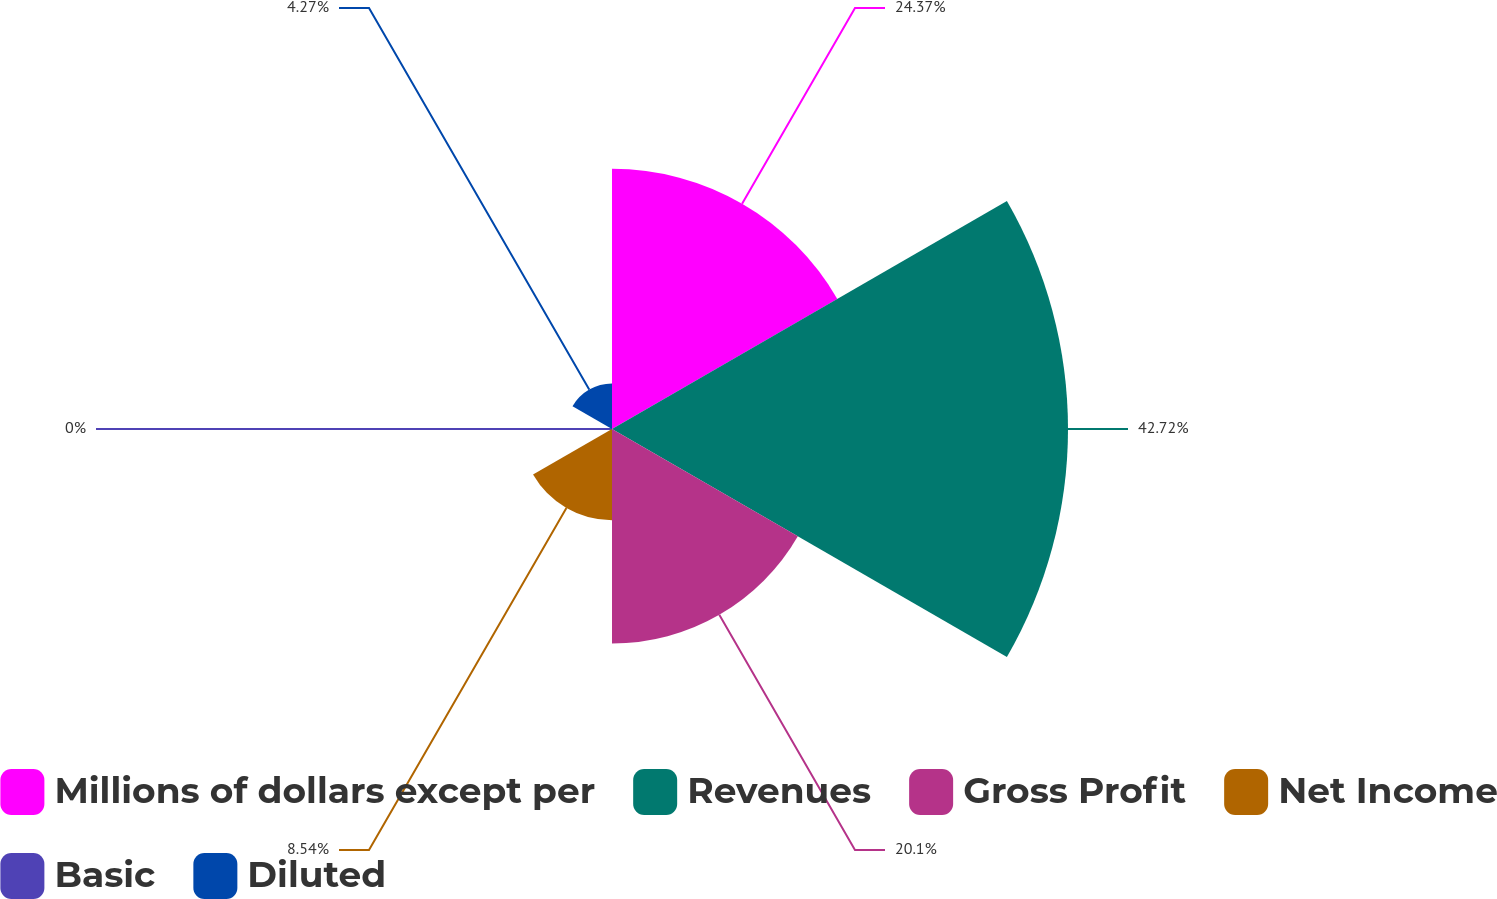Convert chart to OTSL. <chart><loc_0><loc_0><loc_500><loc_500><pie_chart><fcel>Millions of dollars except per<fcel>Revenues<fcel>Gross Profit<fcel>Net Income<fcel>Basic<fcel>Diluted<nl><fcel>24.37%<fcel>42.71%<fcel>20.1%<fcel>8.54%<fcel>0.0%<fcel>4.27%<nl></chart> 